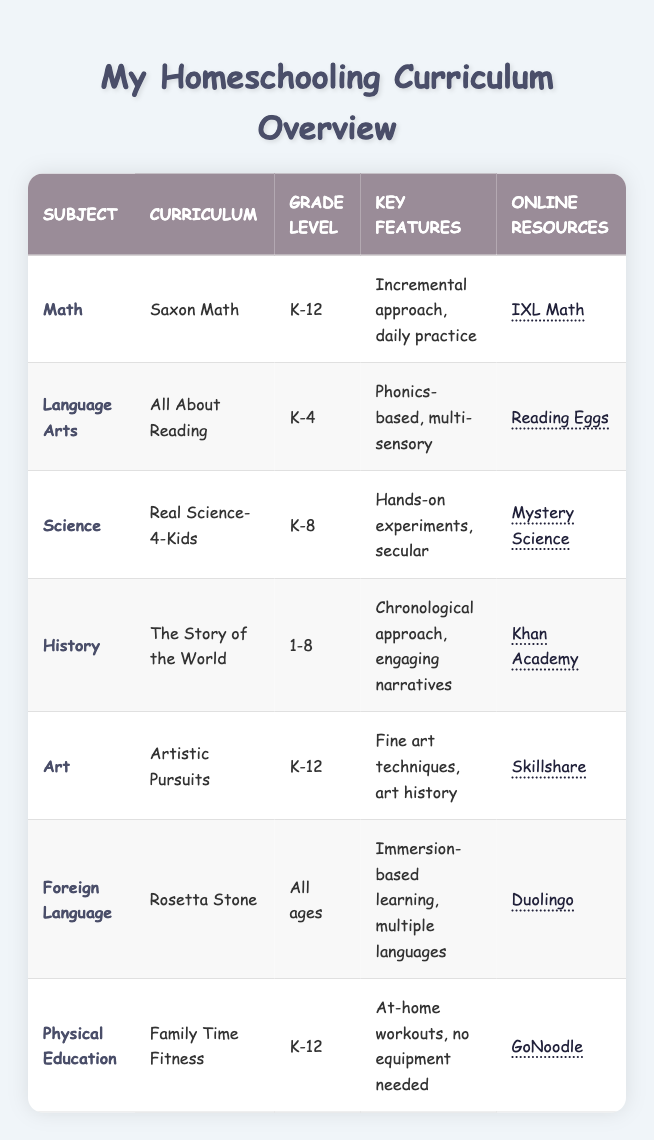What curriculum is used for Language Arts? The table lists the curriculum for Language Arts as "All About Reading." This information is directly obtained from the row corresponding to the Language Arts subject.
Answer: All About Reading Which subjects have a curriculum that is suitable for K-12? The subjects listed for K-12 in the table are Math, Art, and Physical Education, as seen in their respective rows. Each of these subjects displays "K-12" in the Grade Level column.
Answer: Math, Art, Physical Education What key features does the Science curriculum offer? The Science curriculum, "Real Science-4-Kids," is noted for "Hands-on experiments, secular" in its key features. This information is found directly from the Science row in the table.
Answer: Hands-on experiments, secular Is the Foreign Language curriculum suitable for all ages? Yes, the Foreign Language curriculum, "Rosetta Stone," is noted as suitable for "All ages" in the Grade Level column. This can be confirmed directly from the table.
Answer: Yes How many curriculums are available for grades K-4? The table lists two subjects available for grades K-4, which are Language Arts (All About Reading) and Foreign Language (Rosetta Stone), making a total of 2. This is determined by counting the relevant rows in the table.
Answer: 2 What online resource is associated with the History curriculum? According to the table, the online resource for the History curriculum, "The Story of the World," is "Khan Academy." This information can be directly taken from the History row in the table.
Answer: Khan Academy How does the key feature of the Foreign Language curriculum compare to that of Physical Education? The Foreign Language curriculum features "Immersion-based learning, multiple languages," while Physical Education emphasizes "At-home workouts, no equipment needed." This comparison involves looking at the respective key features in their rows in the table.
Answer: Immersion vs. workouts Which subject has the broadest grade level coverage? The subject with the broadest grade level coverage is Math, "K-12," which covers all grades from kindergarten to 12th grade. This is determined by examining the Grade Level column for each subject.
Answer: Math What is the average grade level range for the curriculums listed? The curriculum grade levels range as follows: K-12 (3), K-4 (1), K-8 (2), 1-8 (2), and All ages (1). The average is computed as: (3+1+2+2+1) / 5 = 1.8. The average grade level range for these subjects is calculated by considering their grade levels and dividing by the total number of subjects.
Answer: 1.8 